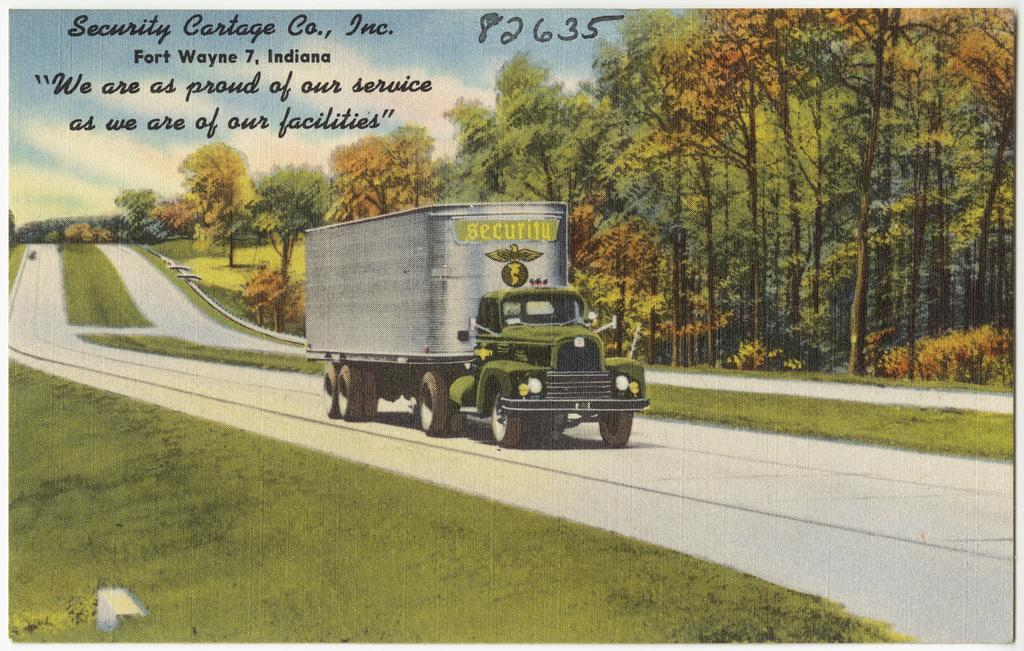What is the main subject of the image? The main subject of the image is a truck. Where is the truck located in the image? The truck is on the road in the image. What can be seen in the background of the image? In the background of the image, there is grass, trees, text, and the sky. Can you describe the time of day when the image was taken? The image was taken during the day. How many eyes can be seen on the truck in the image? There are no eyes visible on the truck in the image, as trucks do not have eyes. What country is the truck from in the image? The image does not provide any information about the country of origin for the truck. 